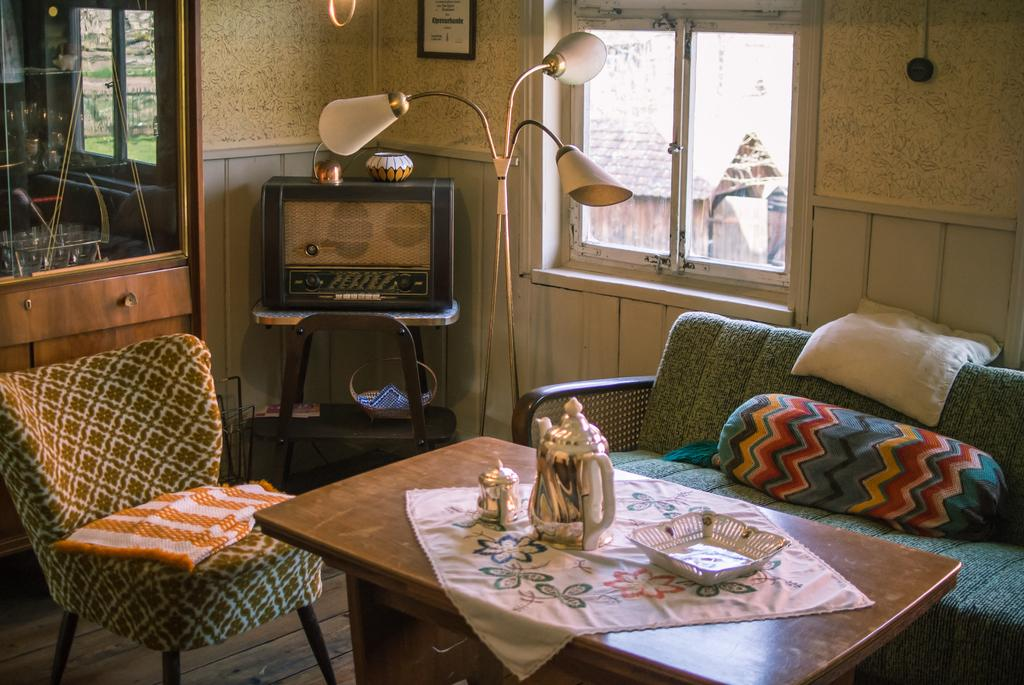What type of furniture is in the image? There is a sofa set and a table in the image. What is placed on the table? There are items on the table. What can be seen in the background of the image? There is a cabinet, a TV, windows, and a frame on the wall in the background of the image. How many suits are hanging in the drawer in the image? There is no drawer or suit visible in the image. What type of zephyr can be seen blowing through the room in the image? There is no zephyr present in the image; it is a room with furniture and other items. 